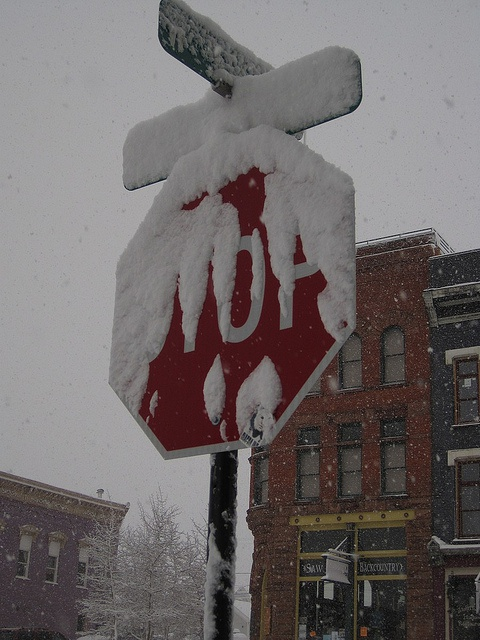Describe the objects in this image and their specific colors. I can see a stop sign in darkgray, gray, and maroon tones in this image. 